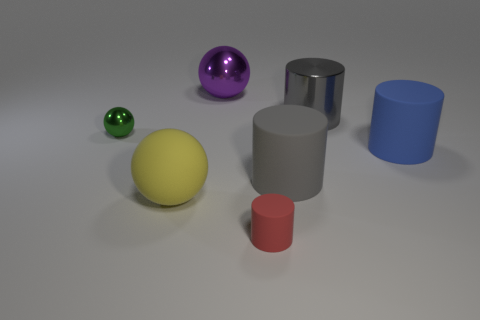Are there any purple balls made of the same material as the green sphere?
Provide a short and direct response. Yes. There is a gray cylinder that is to the left of the gray metal cylinder; does it have the same size as the tiny rubber cylinder?
Your response must be concise. No. What number of red objects are either tiny metallic objects or shiny balls?
Give a very brief answer. 0. There is a small object that is behind the big blue rubber cylinder; what material is it?
Your answer should be compact. Metal. There is a big matte cylinder that is in front of the big blue thing; how many big blue objects are in front of it?
Provide a succinct answer. 0. How many large purple metallic objects have the same shape as the small green object?
Offer a terse response. 1. What number of large shiny cylinders are there?
Your answer should be compact. 1. There is a rubber object that is on the left side of the red object; what is its color?
Provide a short and direct response. Yellow. There is a big cylinder to the right of the large metal object right of the tiny matte thing; what is its color?
Your response must be concise. Blue. There is a metallic cylinder that is the same size as the yellow rubber ball; what color is it?
Offer a very short reply. Gray. 